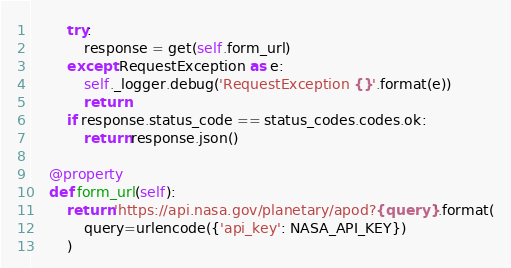<code> <loc_0><loc_0><loc_500><loc_500><_Python_>
        try:
            response = get(self.form_url)
        except RequestException as e:
            self._logger.debug('RequestException {}'.format(e))
            return
        if response.status_code == status_codes.codes.ok:
            return response.json()

    @property
    def form_url(self):
        return 'https://api.nasa.gov/planetary/apod?{query}'.format(
            query=urlencode({'api_key': NASA_API_KEY})
        )
</code> 